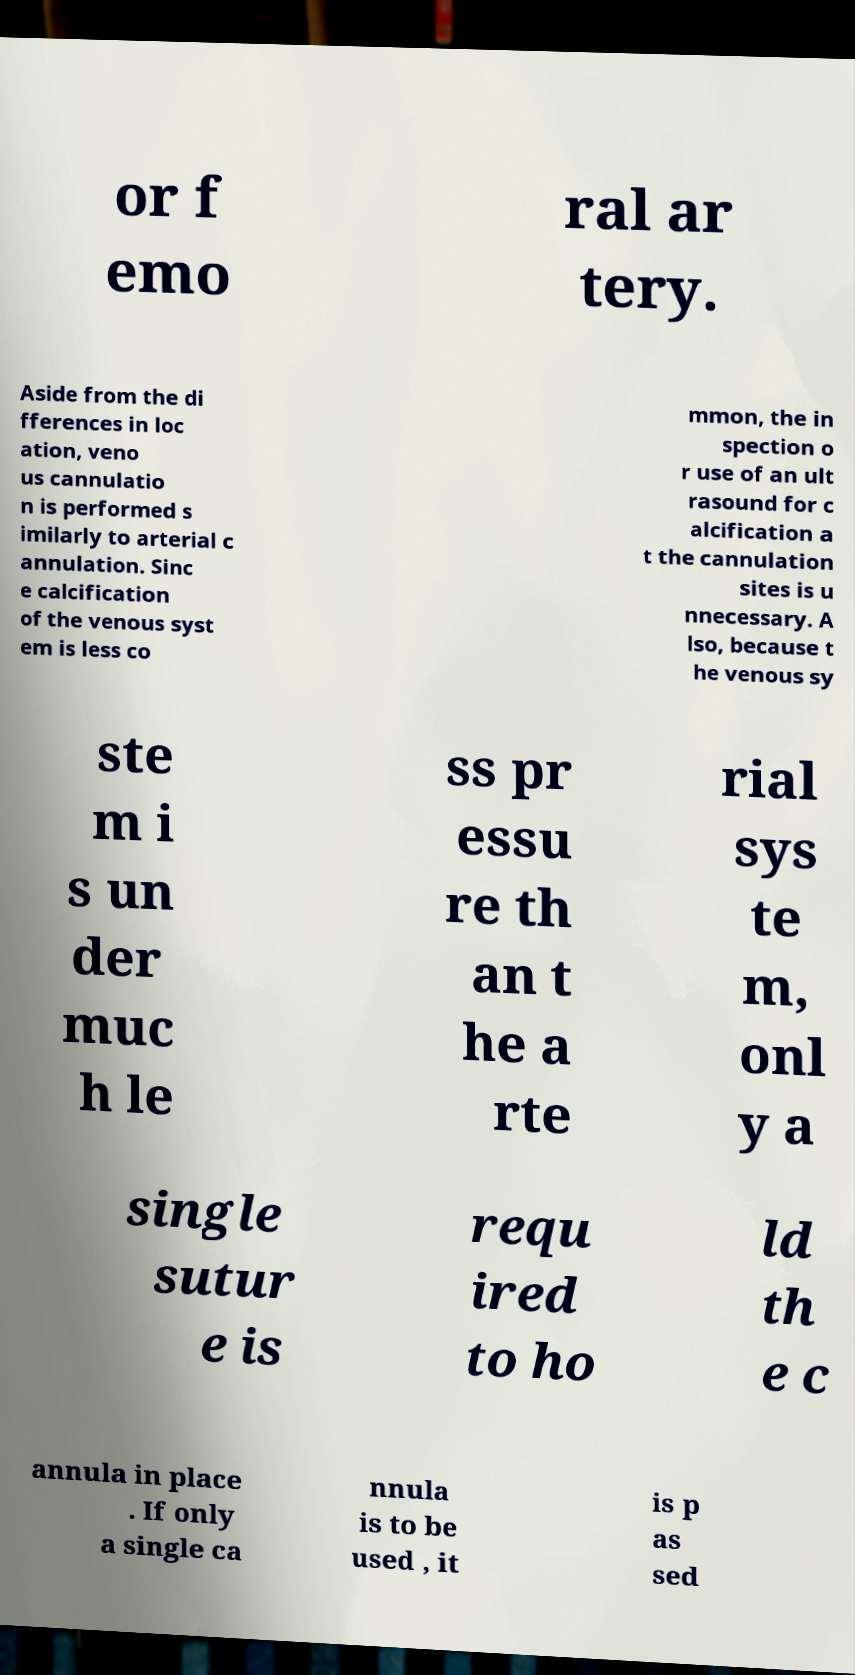Could you assist in decoding the text presented in this image and type it out clearly? or f emo ral ar tery. Aside from the di fferences in loc ation, veno us cannulatio n is performed s imilarly to arterial c annulation. Sinc e calcification of the venous syst em is less co mmon, the in spection o r use of an ult rasound for c alcification a t the cannulation sites is u nnecessary. A lso, because t he venous sy ste m i s un der muc h le ss pr essu re th an t he a rte rial sys te m, onl y a single sutur e is requ ired to ho ld th e c annula in place . If only a single ca nnula is to be used , it is p as sed 